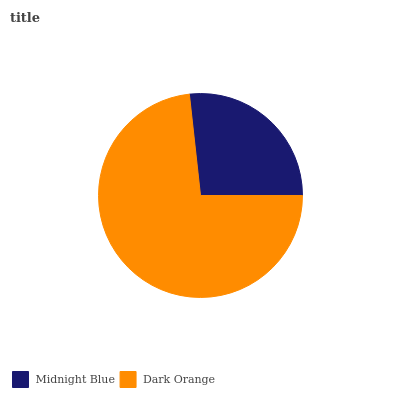Is Midnight Blue the minimum?
Answer yes or no. Yes. Is Dark Orange the maximum?
Answer yes or no. Yes. Is Dark Orange the minimum?
Answer yes or no. No. Is Dark Orange greater than Midnight Blue?
Answer yes or no. Yes. Is Midnight Blue less than Dark Orange?
Answer yes or no. Yes. Is Midnight Blue greater than Dark Orange?
Answer yes or no. No. Is Dark Orange less than Midnight Blue?
Answer yes or no. No. Is Dark Orange the high median?
Answer yes or no. Yes. Is Midnight Blue the low median?
Answer yes or no. Yes. Is Midnight Blue the high median?
Answer yes or no. No. Is Dark Orange the low median?
Answer yes or no. No. 